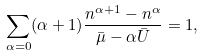Convert formula to latex. <formula><loc_0><loc_0><loc_500><loc_500>\sum _ { \alpha = 0 } ( \alpha + 1 ) \frac { n ^ { \alpha + 1 } - n ^ { \alpha } } { \bar { \mu } - { \alpha } \bar { U } } = 1 ,</formula> 